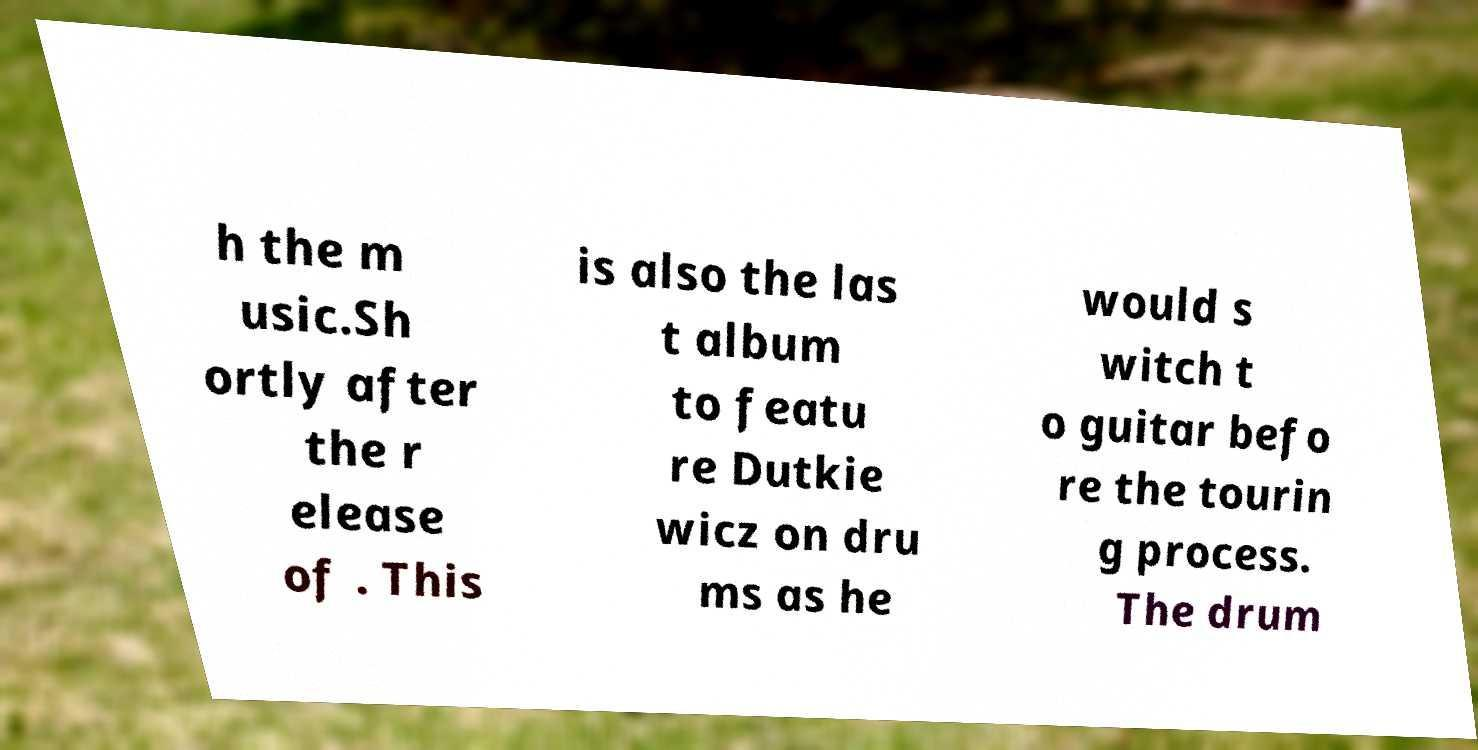Can you read and provide the text displayed in the image?This photo seems to have some interesting text. Can you extract and type it out for me? h the m usic.Sh ortly after the r elease of . This is also the las t album to featu re Dutkie wicz on dru ms as he would s witch t o guitar befo re the tourin g process. The drum 